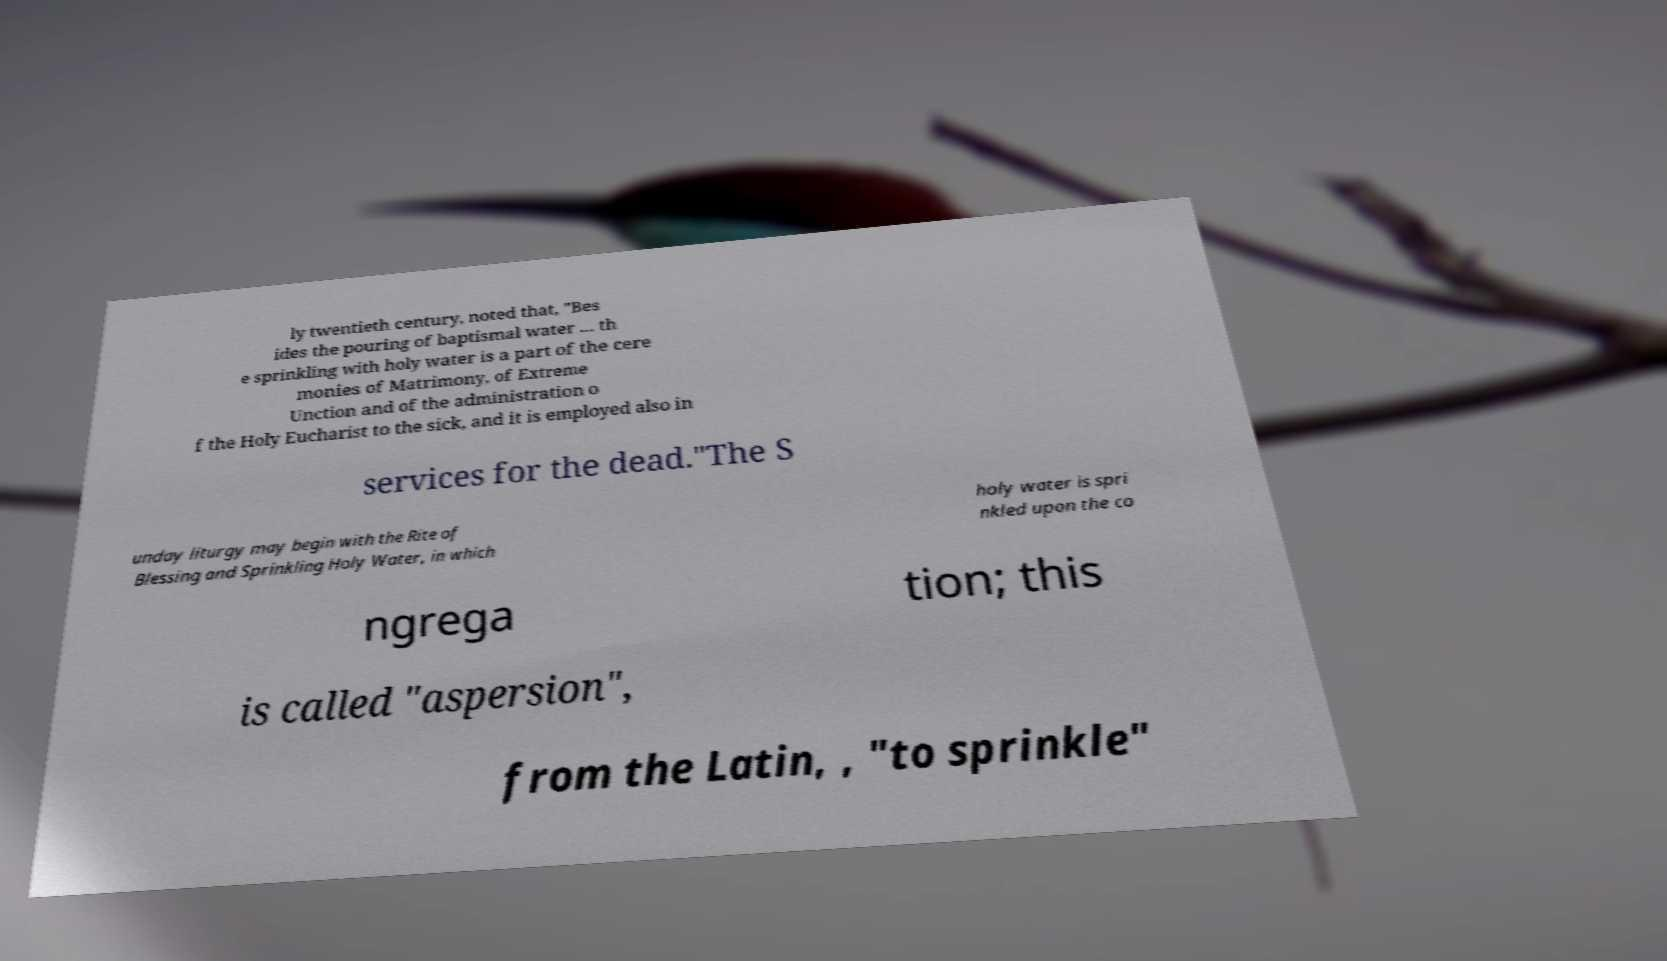Please read and relay the text visible in this image. What does it say? ly twentieth century, noted that, "Bes ides the pouring of baptismal water ... th e sprinkling with holy water is a part of the cere monies of Matrimony, of Extreme Unction and of the administration o f the Holy Eucharist to the sick, and it is employed also in services for the dead."The S unday liturgy may begin with the Rite of Blessing and Sprinkling Holy Water, in which holy water is spri nkled upon the co ngrega tion; this is called "aspersion", from the Latin, , "to sprinkle" 